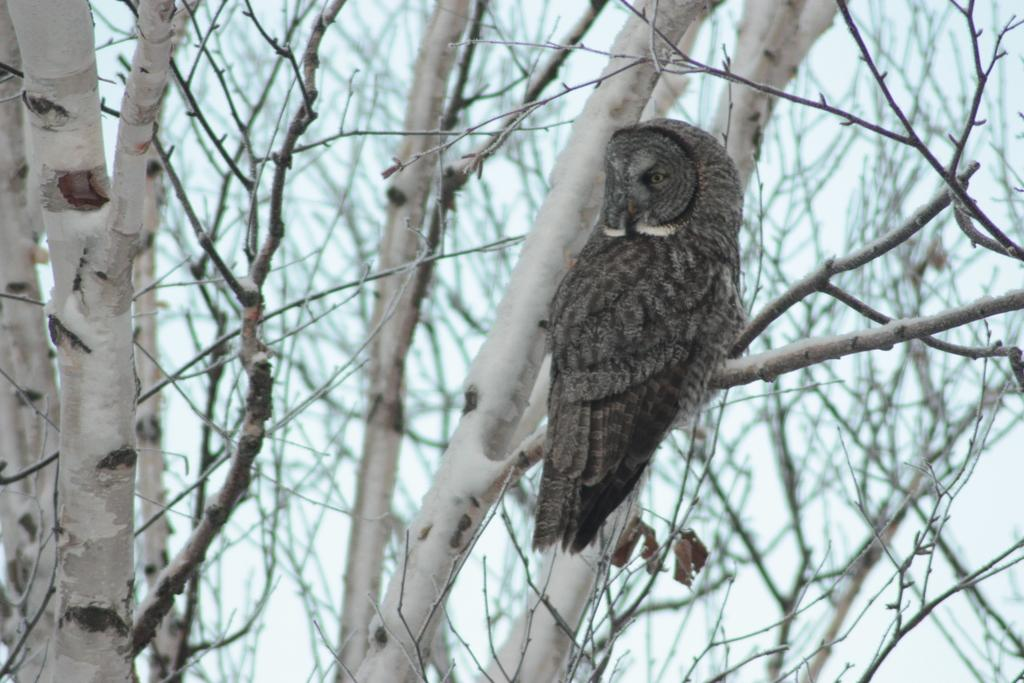What type of vegetation is visible in the image? There are dry trees in the image. Can you describe the bird in the image? There is a bird standing on the branch of a tree in the image. What type of government is depicted in the image? There is no depiction of a government in the image; it features dry trees and a bird. What type of notebook is visible in the image? There is no notebook present in the image. 